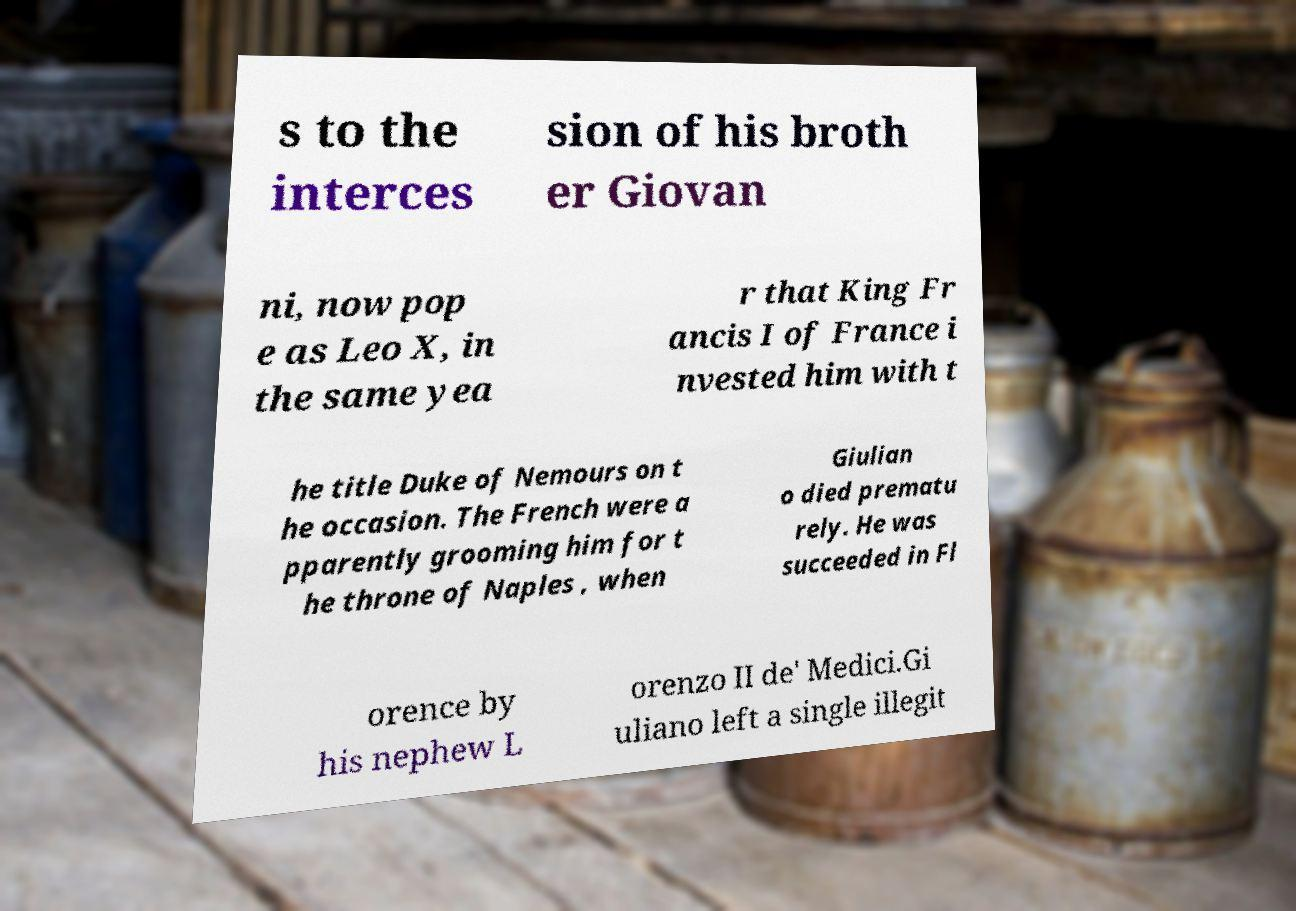What messages or text are displayed in this image? I need them in a readable, typed format. s to the interces sion of his broth er Giovan ni, now pop e as Leo X, in the same yea r that King Fr ancis I of France i nvested him with t he title Duke of Nemours on t he occasion. The French were a pparently grooming him for t he throne of Naples , when Giulian o died prematu rely. He was succeeded in Fl orence by his nephew L orenzo II de' Medici.Gi uliano left a single illegit 